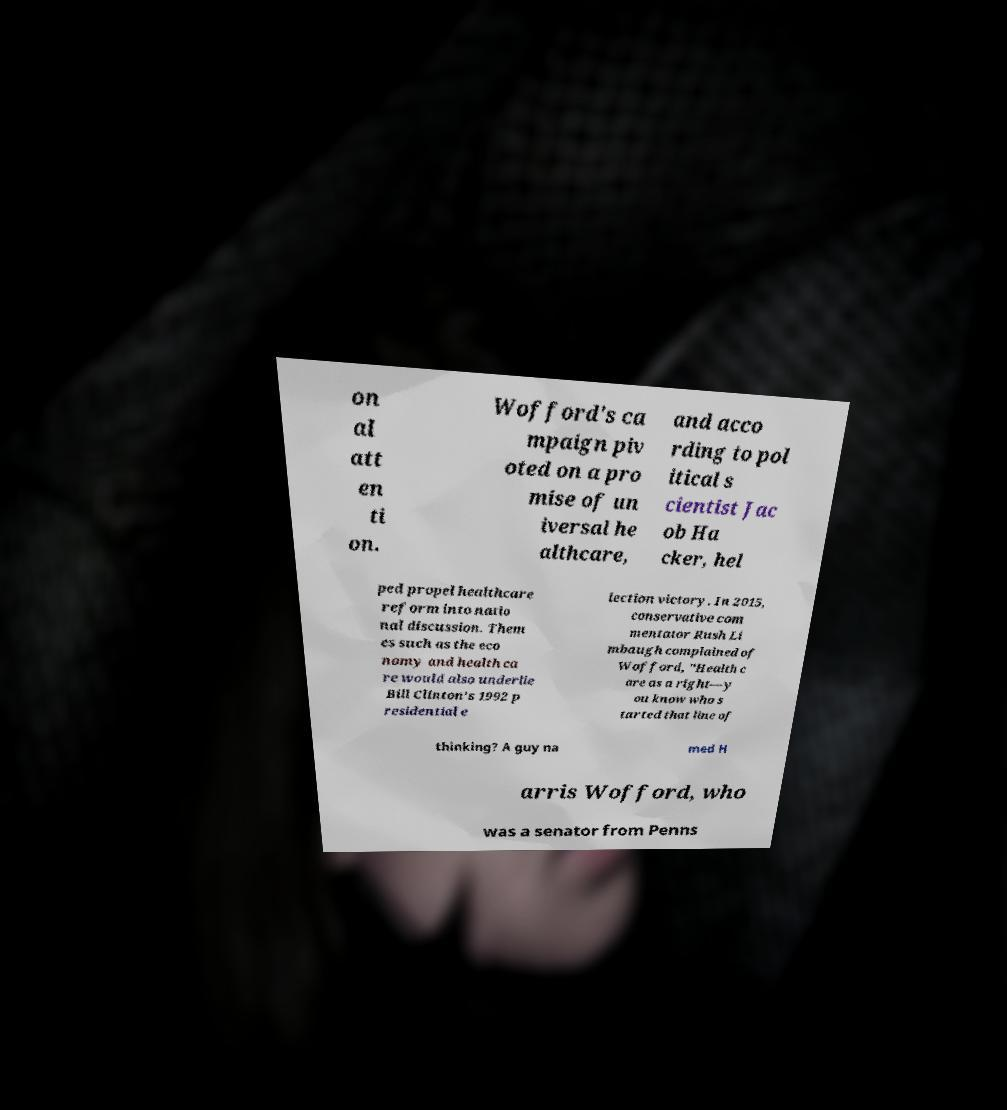Can you read and provide the text displayed in the image?This photo seems to have some interesting text. Can you extract and type it out for me? on al att en ti on. Wofford's ca mpaign piv oted on a pro mise of un iversal he althcare, and acco rding to pol itical s cientist Jac ob Ha cker, hel ped propel healthcare reform into natio nal discussion. Them es such as the eco nomy and health ca re would also underlie Bill Clinton's 1992 p residential e lection victory. In 2015, conservative com mentator Rush Li mbaugh complained of Wofford, "Health c are as a right—y ou know who s tarted that line of thinking? A guy na med H arris Wofford, who was a senator from Penns 